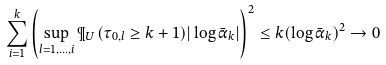Convert formula to latex. <formula><loc_0><loc_0><loc_500><loc_500>\sum _ { i = 1 } ^ { k } \left ( \sup _ { l = 1 , \dots , i } \P _ { U } ( \tau _ { 0 , l } \geq k + 1 ) | \log \bar { \alpha } _ { k } | \right ) ^ { 2 } \leq k ( \log \bar { \alpha } _ { k } ) ^ { 2 } \rightarrow 0</formula> 